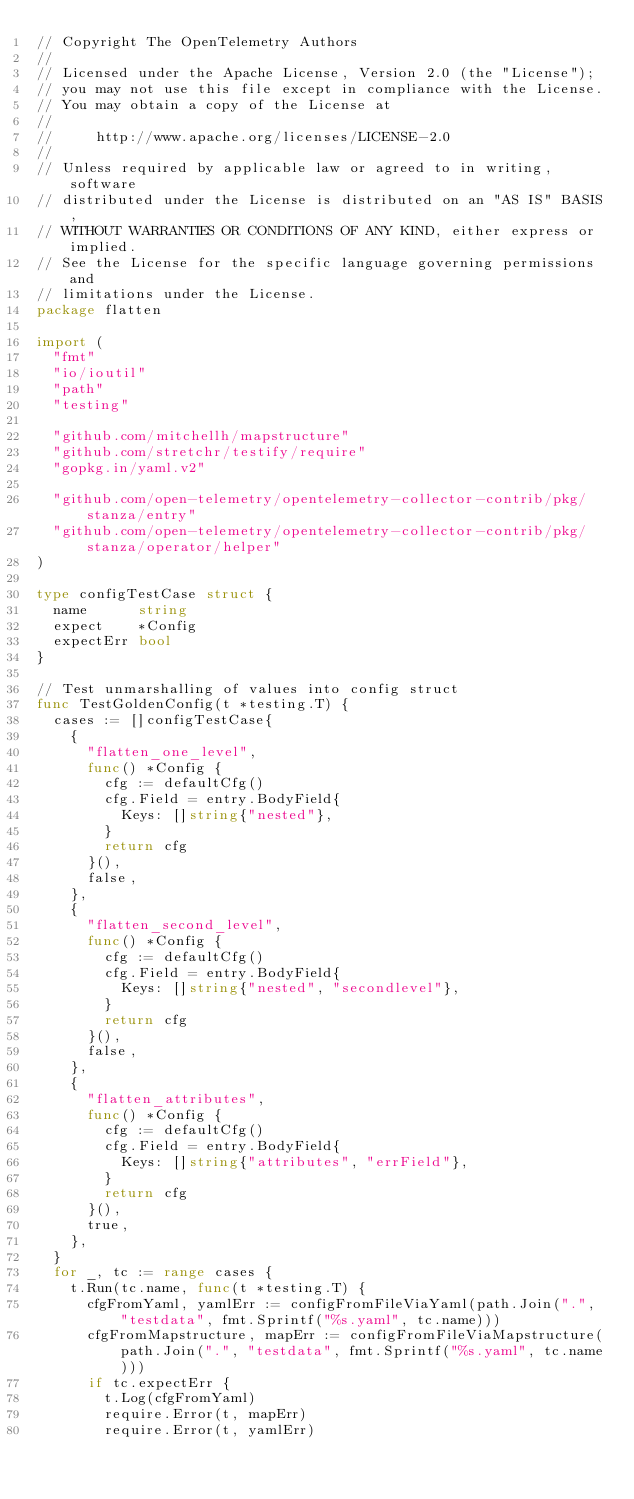<code> <loc_0><loc_0><loc_500><loc_500><_Go_>// Copyright The OpenTelemetry Authors
//
// Licensed under the Apache License, Version 2.0 (the "License");
// you may not use this file except in compliance with the License.
// You may obtain a copy of the License at
//
//     http://www.apache.org/licenses/LICENSE-2.0
//
// Unless required by applicable law or agreed to in writing, software
// distributed under the License is distributed on an "AS IS" BASIS,
// WITHOUT WARRANTIES OR CONDITIONS OF ANY KIND, either express or implied.
// See the License for the specific language governing permissions and
// limitations under the License.
package flatten

import (
	"fmt"
	"io/ioutil"
	"path"
	"testing"

	"github.com/mitchellh/mapstructure"
	"github.com/stretchr/testify/require"
	"gopkg.in/yaml.v2"

	"github.com/open-telemetry/opentelemetry-collector-contrib/pkg/stanza/entry"
	"github.com/open-telemetry/opentelemetry-collector-contrib/pkg/stanza/operator/helper"
)

type configTestCase struct {
	name      string
	expect    *Config
	expectErr bool
}

// Test unmarshalling of values into config struct
func TestGoldenConfig(t *testing.T) {
	cases := []configTestCase{
		{
			"flatten_one_level",
			func() *Config {
				cfg := defaultCfg()
				cfg.Field = entry.BodyField{
					Keys: []string{"nested"},
				}
				return cfg
			}(),
			false,
		},
		{
			"flatten_second_level",
			func() *Config {
				cfg := defaultCfg()
				cfg.Field = entry.BodyField{
					Keys: []string{"nested", "secondlevel"},
				}
				return cfg
			}(),
			false,
		},
		{
			"flatten_attributes",
			func() *Config {
				cfg := defaultCfg()
				cfg.Field = entry.BodyField{
					Keys: []string{"attributes", "errField"},
				}
				return cfg
			}(),
			true,
		},
	}
	for _, tc := range cases {
		t.Run(tc.name, func(t *testing.T) {
			cfgFromYaml, yamlErr := configFromFileViaYaml(path.Join(".", "testdata", fmt.Sprintf("%s.yaml", tc.name)))
			cfgFromMapstructure, mapErr := configFromFileViaMapstructure(path.Join(".", "testdata", fmt.Sprintf("%s.yaml", tc.name)))
			if tc.expectErr {
				t.Log(cfgFromYaml)
				require.Error(t, mapErr)
				require.Error(t, yamlErr)</code> 